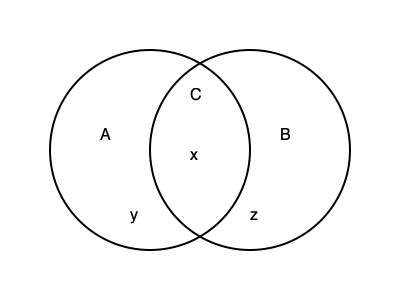As a cognitive scientist examining the intersection of logic and human cognition, consider the Venn diagram above representing three sets: A, B, and C. If we know that "All C are A" and "No B are C," what can we conclude about the regions labeled x, y, and z in terms of their logical possibility or impossibility? To answer this question, let's analyze the given premises and their implications on the Venn diagram:

1. "All C are A":
   This means that the set C is entirely contained within set A. Therefore, there can be no part of C outside of A.

2. "No B are C":
   This indicates that sets B and C are mutually exclusive, having no overlap.

Now, let's examine each region:

a) Region x:
   This is the intersection of A and B, but not C. Given our premises, this region is logically possible. It represents elements that are both A and B, but not C.

b) Region y:
   This is the part of A that is neither B nor C. This region is also logically possible, as it doesn't contradict either premise.

c) Region z:
   This is the part of B that is outside both A and C. This region is logically possible and must exist because we know that no B can be C, and C is entirely within A.

The key insight is that the entire set C must be contained within A but cannot overlap with B at all. This forces C to be entirely within the part of A that doesn't intersect with B.

Therefore, we can conclude that all three regions (x, y, and z) are logically possible given the premises. The only region that becomes logically impossible is the intersection of all three sets (A, B, and C), which isn't labeled in this diagram but would be located in the center overlap of all three circles.
Answer: All regions (x, y, z) are logically possible. 